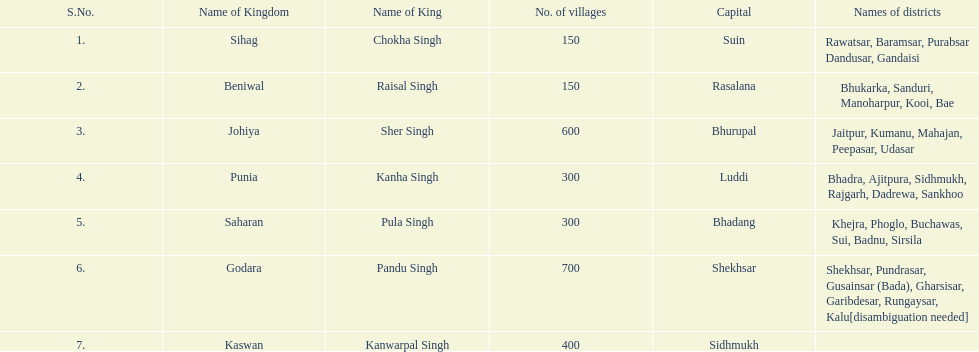Give me the full table as a dictionary. {'header': ['S.No.', 'Name of Kingdom', 'Name of King', 'No. of villages', 'Capital', 'Names of districts'], 'rows': [['1.', 'Sihag', 'Chokha Singh', '150', 'Suin', 'Rawatsar, Baramsar, Purabsar Dandusar, Gandaisi'], ['2.', 'Beniwal', 'Raisal Singh', '150', 'Rasalana', 'Bhukarka, Sanduri, Manoharpur, Kooi, Bae'], ['3.', 'Johiya', 'Sher Singh', '600', 'Bhurupal', 'Jaitpur, Kumanu, Mahajan, Peepasar, Udasar'], ['4.', 'Punia', 'Kanha Singh', '300', 'Luddi', 'Bhadra, Ajitpura, Sidhmukh, Rajgarh, Dadrewa, Sankhoo'], ['5.', 'Saharan', 'Pula Singh', '300', 'Bhadang', 'Khejra, Phoglo, Buchawas, Sui, Badnu, Sirsila'], ['6.', 'Godara', 'Pandu Singh', '700', 'Shekhsar', 'Shekhsar, Pundrasar, Gusainsar (Bada), Gharsisar, Garibdesar, Rungaysar, Kalu[disambiguation needed]'], ['7.', 'Kaswan', 'Kanwarpal Singh', '400', 'Sidhmukh', '']]} What is the following kingdom listed after sihag? Beniwal. 